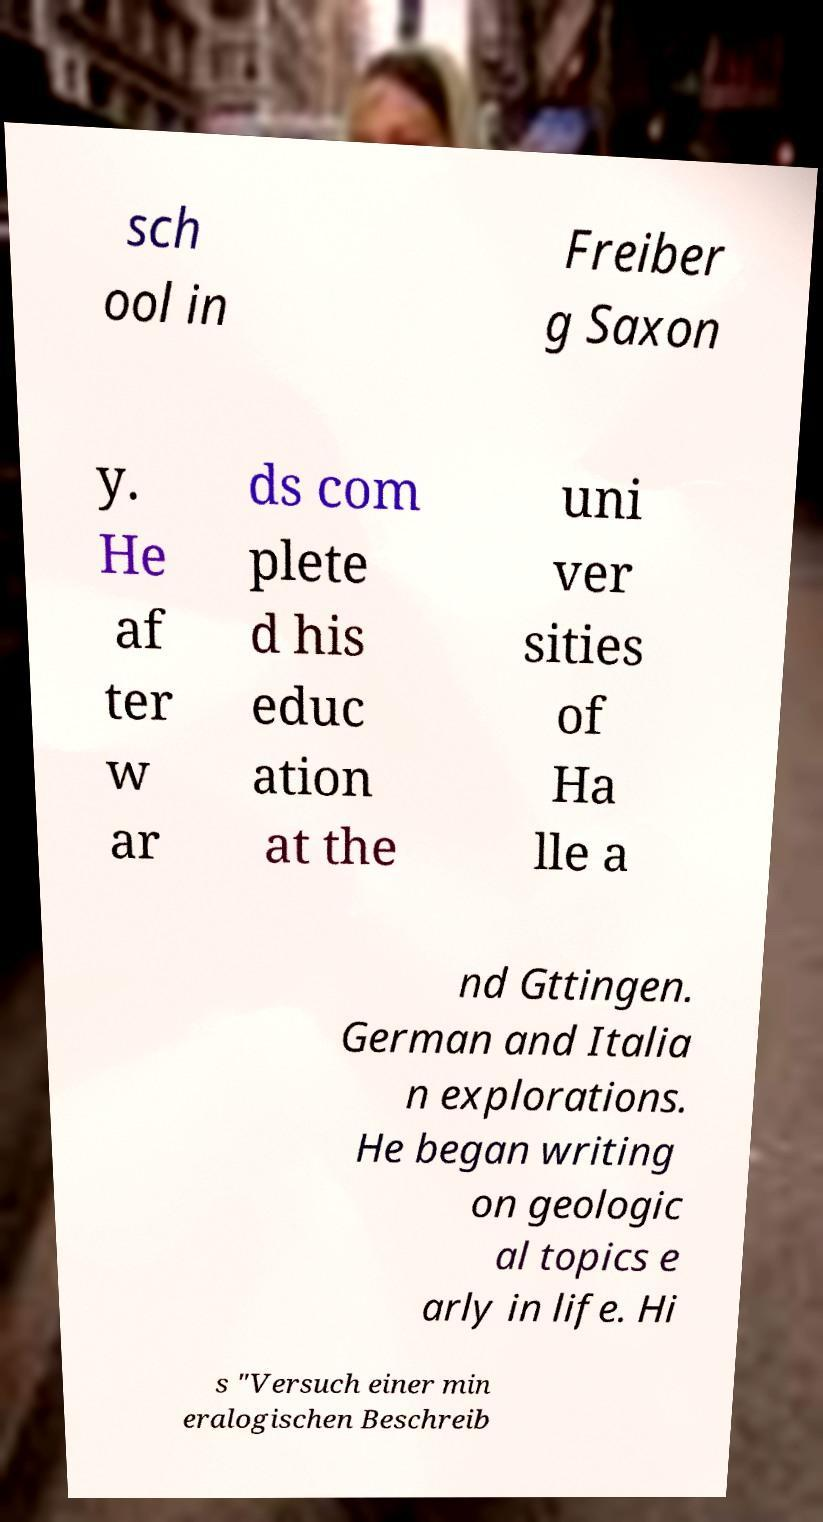I need the written content from this picture converted into text. Can you do that? sch ool in Freiber g Saxon y. He af ter w ar ds com plete d his educ ation at the uni ver sities of Ha lle a nd Gttingen. German and Italia n explorations. He began writing on geologic al topics e arly in life. Hi s "Versuch einer min eralogischen Beschreib 